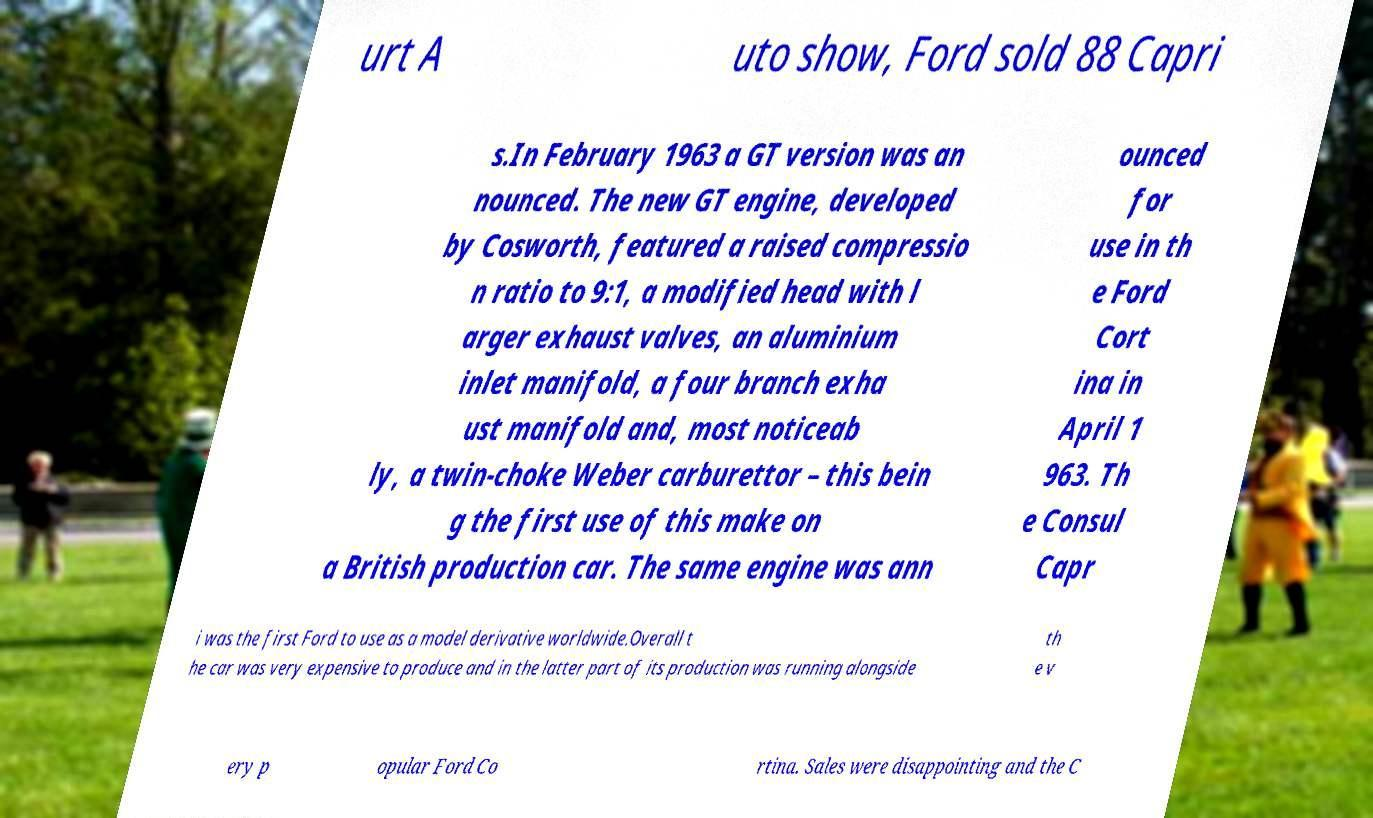Can you read and provide the text displayed in the image?This photo seems to have some interesting text. Can you extract and type it out for me? urt A uto show, Ford sold 88 Capri s.In February 1963 a GT version was an nounced. The new GT engine, developed by Cosworth, featured a raised compressio n ratio to 9:1, a modified head with l arger exhaust valves, an aluminium inlet manifold, a four branch exha ust manifold and, most noticeab ly, a twin-choke Weber carburettor – this bein g the first use of this make on a British production car. The same engine was ann ounced for use in th e Ford Cort ina in April 1 963. Th e Consul Capr i was the first Ford to use as a model derivative worldwide.Overall t he car was very expensive to produce and in the latter part of its production was running alongside th e v ery p opular Ford Co rtina. Sales were disappointing and the C 